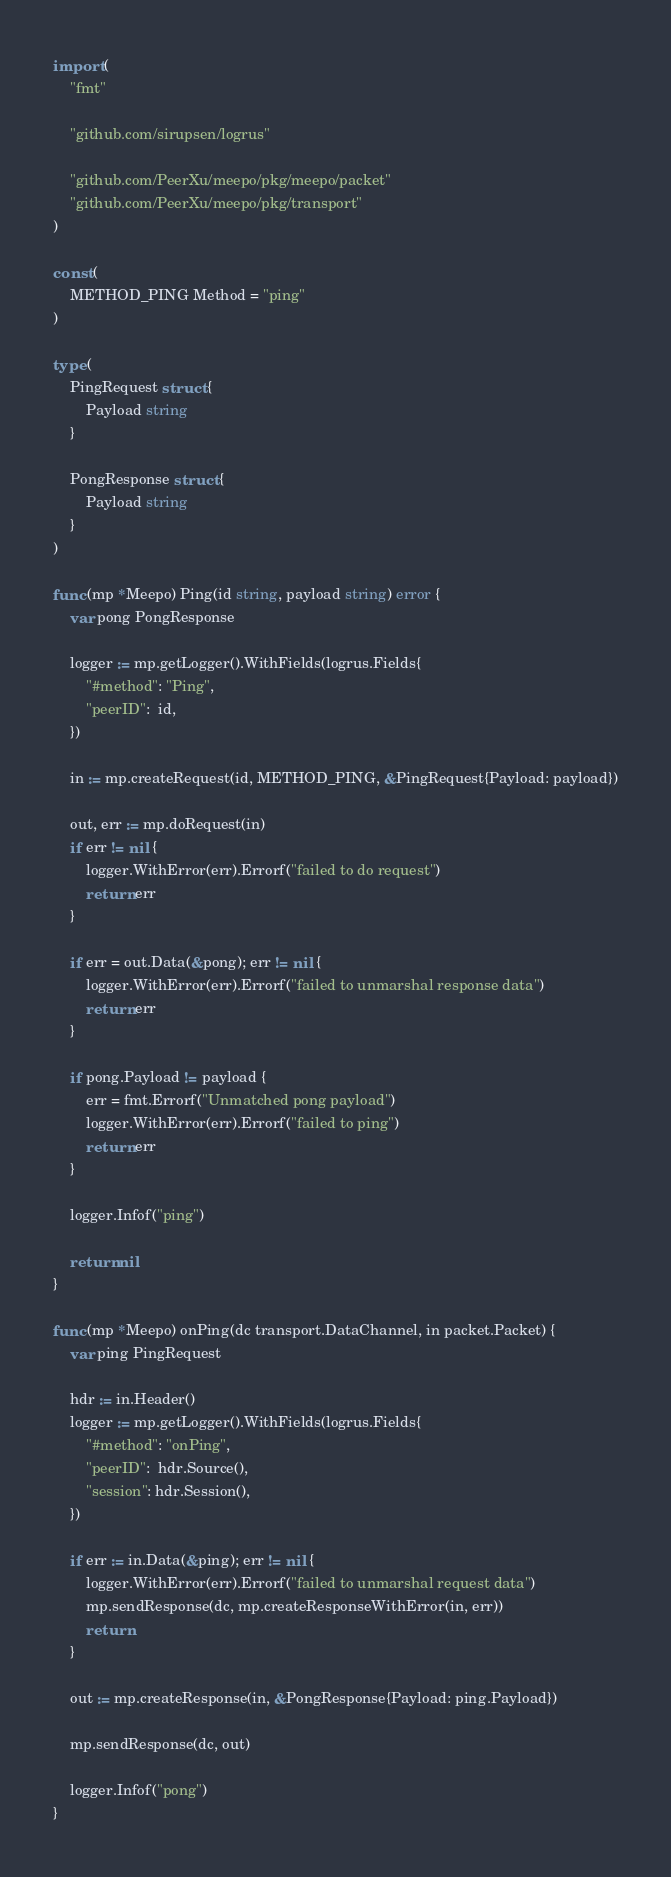<code> <loc_0><loc_0><loc_500><loc_500><_Go_>import (
	"fmt"

	"github.com/sirupsen/logrus"

	"github.com/PeerXu/meepo/pkg/meepo/packet"
	"github.com/PeerXu/meepo/pkg/transport"
)

const (
	METHOD_PING Method = "ping"
)

type (
	PingRequest struct {
		Payload string
	}

	PongResponse struct {
		Payload string
	}
)

func (mp *Meepo) Ping(id string, payload string) error {
	var pong PongResponse

	logger := mp.getLogger().WithFields(logrus.Fields{
		"#method": "Ping",
		"peerID":  id,
	})

	in := mp.createRequest(id, METHOD_PING, &PingRequest{Payload: payload})

	out, err := mp.doRequest(in)
	if err != nil {
		logger.WithError(err).Errorf("failed to do request")
		return err
	}

	if err = out.Data(&pong); err != nil {
		logger.WithError(err).Errorf("failed to unmarshal response data")
		return err
	}

	if pong.Payload != payload {
		err = fmt.Errorf("Unmatched pong payload")
		logger.WithError(err).Errorf("failed to ping")
		return err
	}

	logger.Infof("ping")

	return nil
}

func (mp *Meepo) onPing(dc transport.DataChannel, in packet.Packet) {
	var ping PingRequest

	hdr := in.Header()
	logger := mp.getLogger().WithFields(logrus.Fields{
		"#method": "onPing",
		"peerID":  hdr.Source(),
		"session": hdr.Session(),
	})

	if err := in.Data(&ping); err != nil {
		logger.WithError(err).Errorf("failed to unmarshal request data")
		mp.sendResponse(dc, mp.createResponseWithError(in, err))
		return
	}

	out := mp.createResponse(in, &PongResponse{Payload: ping.Payload})

	mp.sendResponse(dc, out)

	logger.Infof("pong")
}
</code> 